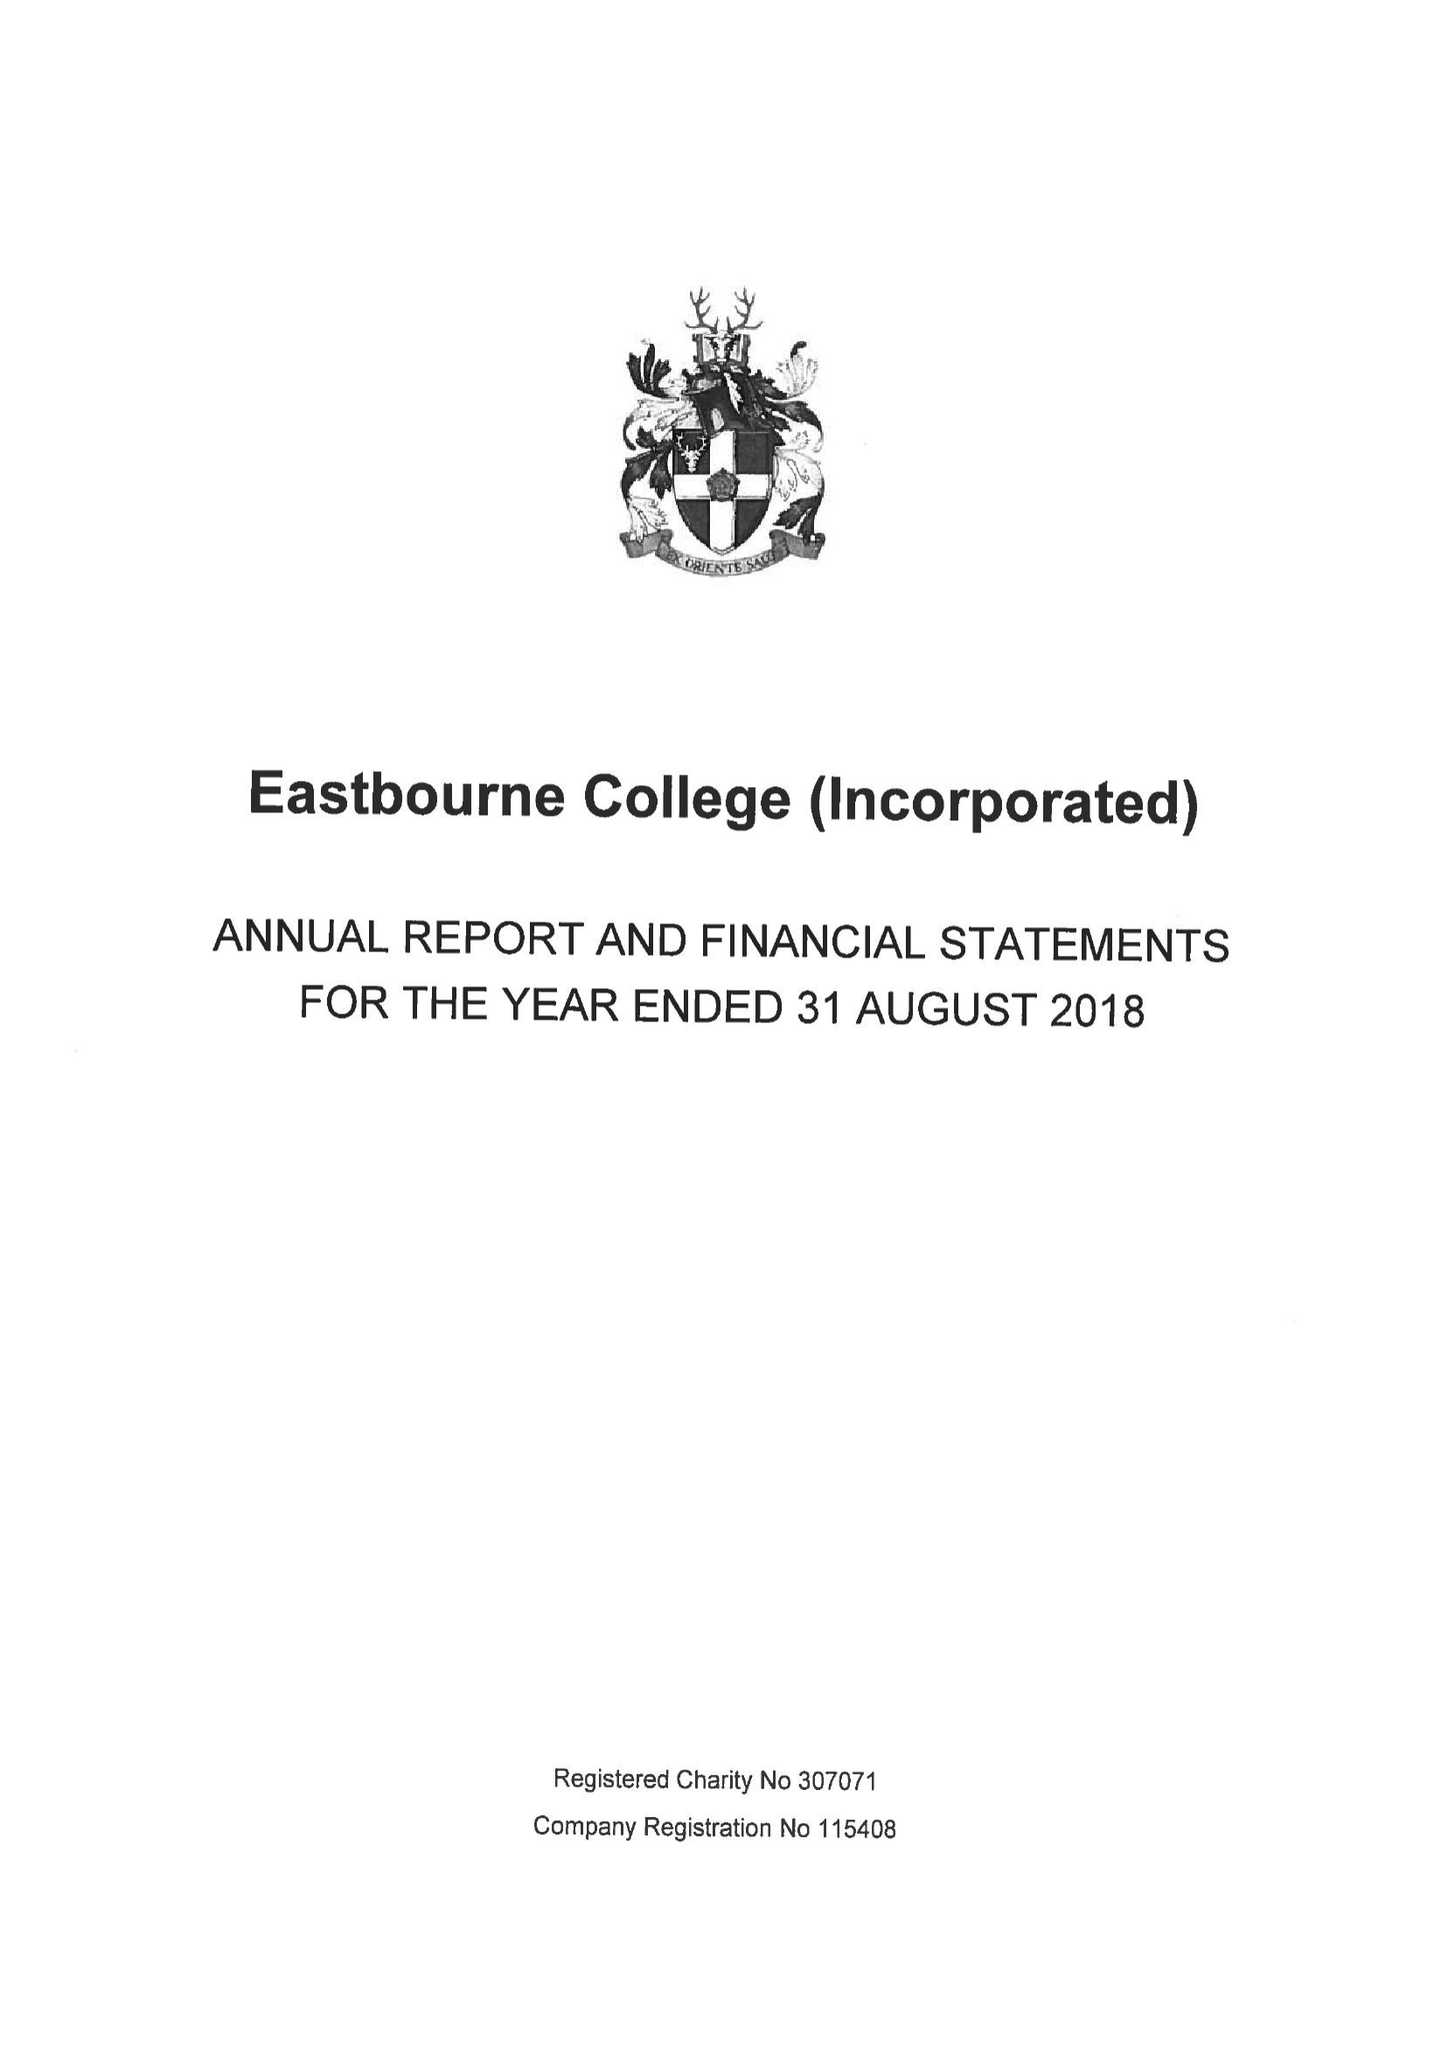What is the value for the income_annually_in_british_pounds?
Answer the question using a single word or phrase. 23088000.00 